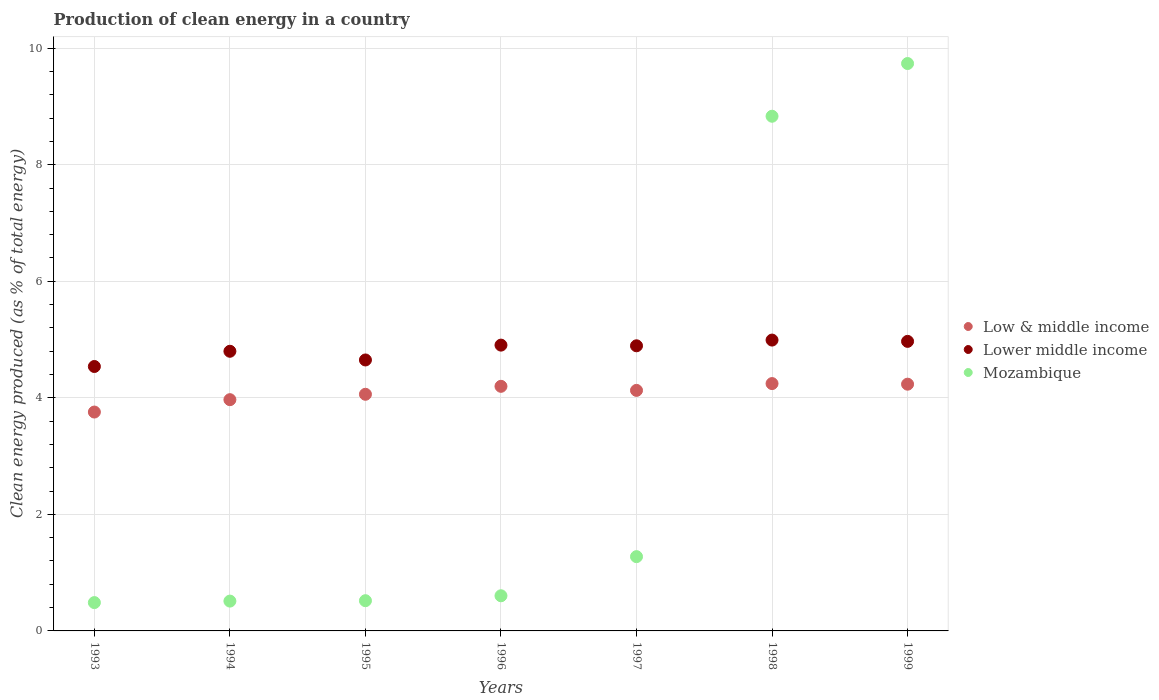How many different coloured dotlines are there?
Your response must be concise. 3. What is the percentage of clean energy produced in Mozambique in 1995?
Offer a very short reply. 0.52. Across all years, what is the maximum percentage of clean energy produced in Mozambique?
Your answer should be very brief. 9.74. Across all years, what is the minimum percentage of clean energy produced in Lower middle income?
Give a very brief answer. 4.54. What is the total percentage of clean energy produced in Mozambique in the graph?
Your response must be concise. 21.96. What is the difference between the percentage of clean energy produced in Low & middle income in 1998 and that in 1999?
Your response must be concise. 0.01. What is the difference between the percentage of clean energy produced in Low & middle income in 1995 and the percentage of clean energy produced in Mozambique in 1997?
Provide a short and direct response. 2.79. What is the average percentage of clean energy produced in Mozambique per year?
Your answer should be compact. 3.14. In the year 1996, what is the difference between the percentage of clean energy produced in Mozambique and percentage of clean energy produced in Lower middle income?
Your response must be concise. -4.3. In how many years, is the percentage of clean energy produced in Low & middle income greater than 7.6 %?
Give a very brief answer. 0. What is the ratio of the percentage of clean energy produced in Mozambique in 1997 to that in 1999?
Provide a succinct answer. 0.13. Is the difference between the percentage of clean energy produced in Mozambique in 1993 and 1995 greater than the difference between the percentage of clean energy produced in Lower middle income in 1993 and 1995?
Offer a terse response. Yes. What is the difference between the highest and the second highest percentage of clean energy produced in Mozambique?
Make the answer very short. 0.9. What is the difference between the highest and the lowest percentage of clean energy produced in Lower middle income?
Your response must be concise. 0.45. How many years are there in the graph?
Your answer should be compact. 7. What is the difference between two consecutive major ticks on the Y-axis?
Offer a terse response. 2. Are the values on the major ticks of Y-axis written in scientific E-notation?
Your response must be concise. No. Does the graph contain any zero values?
Your answer should be compact. No. Does the graph contain grids?
Offer a very short reply. Yes. How many legend labels are there?
Your answer should be compact. 3. How are the legend labels stacked?
Ensure brevity in your answer.  Vertical. What is the title of the graph?
Your answer should be compact. Production of clean energy in a country. Does "Least developed countries" appear as one of the legend labels in the graph?
Offer a terse response. No. What is the label or title of the Y-axis?
Provide a short and direct response. Clean energy produced (as % of total energy). What is the Clean energy produced (as % of total energy) of Low & middle income in 1993?
Give a very brief answer. 3.76. What is the Clean energy produced (as % of total energy) in Lower middle income in 1993?
Keep it short and to the point. 4.54. What is the Clean energy produced (as % of total energy) in Mozambique in 1993?
Make the answer very short. 0.49. What is the Clean energy produced (as % of total energy) in Low & middle income in 1994?
Give a very brief answer. 3.97. What is the Clean energy produced (as % of total energy) of Lower middle income in 1994?
Ensure brevity in your answer.  4.8. What is the Clean energy produced (as % of total energy) in Mozambique in 1994?
Ensure brevity in your answer.  0.51. What is the Clean energy produced (as % of total energy) in Low & middle income in 1995?
Offer a very short reply. 4.06. What is the Clean energy produced (as % of total energy) in Lower middle income in 1995?
Keep it short and to the point. 4.65. What is the Clean energy produced (as % of total energy) of Mozambique in 1995?
Provide a succinct answer. 0.52. What is the Clean energy produced (as % of total energy) in Low & middle income in 1996?
Offer a very short reply. 4.2. What is the Clean energy produced (as % of total energy) of Lower middle income in 1996?
Give a very brief answer. 4.9. What is the Clean energy produced (as % of total energy) of Mozambique in 1996?
Ensure brevity in your answer.  0.6. What is the Clean energy produced (as % of total energy) in Low & middle income in 1997?
Ensure brevity in your answer.  4.13. What is the Clean energy produced (as % of total energy) of Lower middle income in 1997?
Provide a succinct answer. 4.89. What is the Clean energy produced (as % of total energy) in Mozambique in 1997?
Keep it short and to the point. 1.27. What is the Clean energy produced (as % of total energy) of Low & middle income in 1998?
Give a very brief answer. 4.24. What is the Clean energy produced (as % of total energy) of Lower middle income in 1998?
Provide a succinct answer. 4.99. What is the Clean energy produced (as % of total energy) in Mozambique in 1998?
Your answer should be very brief. 8.83. What is the Clean energy produced (as % of total energy) of Low & middle income in 1999?
Your response must be concise. 4.23. What is the Clean energy produced (as % of total energy) of Lower middle income in 1999?
Offer a very short reply. 4.97. What is the Clean energy produced (as % of total energy) in Mozambique in 1999?
Your answer should be compact. 9.74. Across all years, what is the maximum Clean energy produced (as % of total energy) in Low & middle income?
Your answer should be compact. 4.24. Across all years, what is the maximum Clean energy produced (as % of total energy) of Lower middle income?
Make the answer very short. 4.99. Across all years, what is the maximum Clean energy produced (as % of total energy) in Mozambique?
Make the answer very short. 9.74. Across all years, what is the minimum Clean energy produced (as % of total energy) in Low & middle income?
Make the answer very short. 3.76. Across all years, what is the minimum Clean energy produced (as % of total energy) of Lower middle income?
Your answer should be very brief. 4.54. Across all years, what is the minimum Clean energy produced (as % of total energy) of Mozambique?
Give a very brief answer. 0.49. What is the total Clean energy produced (as % of total energy) of Low & middle income in the graph?
Provide a short and direct response. 28.59. What is the total Clean energy produced (as % of total energy) of Lower middle income in the graph?
Keep it short and to the point. 33.74. What is the total Clean energy produced (as % of total energy) in Mozambique in the graph?
Offer a very short reply. 21.96. What is the difference between the Clean energy produced (as % of total energy) of Low & middle income in 1993 and that in 1994?
Provide a short and direct response. -0.21. What is the difference between the Clean energy produced (as % of total energy) in Lower middle income in 1993 and that in 1994?
Offer a terse response. -0.26. What is the difference between the Clean energy produced (as % of total energy) in Mozambique in 1993 and that in 1994?
Provide a short and direct response. -0.03. What is the difference between the Clean energy produced (as % of total energy) of Low & middle income in 1993 and that in 1995?
Give a very brief answer. -0.3. What is the difference between the Clean energy produced (as % of total energy) in Lower middle income in 1993 and that in 1995?
Your response must be concise. -0.11. What is the difference between the Clean energy produced (as % of total energy) in Mozambique in 1993 and that in 1995?
Offer a very short reply. -0.03. What is the difference between the Clean energy produced (as % of total energy) of Low & middle income in 1993 and that in 1996?
Offer a terse response. -0.44. What is the difference between the Clean energy produced (as % of total energy) in Lower middle income in 1993 and that in 1996?
Offer a very short reply. -0.37. What is the difference between the Clean energy produced (as % of total energy) in Mozambique in 1993 and that in 1996?
Your answer should be compact. -0.12. What is the difference between the Clean energy produced (as % of total energy) in Low & middle income in 1993 and that in 1997?
Make the answer very short. -0.37. What is the difference between the Clean energy produced (as % of total energy) in Lower middle income in 1993 and that in 1997?
Your response must be concise. -0.36. What is the difference between the Clean energy produced (as % of total energy) in Mozambique in 1993 and that in 1997?
Your response must be concise. -0.79. What is the difference between the Clean energy produced (as % of total energy) in Low & middle income in 1993 and that in 1998?
Ensure brevity in your answer.  -0.49. What is the difference between the Clean energy produced (as % of total energy) in Lower middle income in 1993 and that in 1998?
Your answer should be compact. -0.45. What is the difference between the Clean energy produced (as % of total energy) of Mozambique in 1993 and that in 1998?
Give a very brief answer. -8.35. What is the difference between the Clean energy produced (as % of total energy) of Low & middle income in 1993 and that in 1999?
Your answer should be very brief. -0.48. What is the difference between the Clean energy produced (as % of total energy) of Lower middle income in 1993 and that in 1999?
Your response must be concise. -0.43. What is the difference between the Clean energy produced (as % of total energy) in Mozambique in 1993 and that in 1999?
Offer a terse response. -9.25. What is the difference between the Clean energy produced (as % of total energy) of Low & middle income in 1994 and that in 1995?
Provide a short and direct response. -0.09. What is the difference between the Clean energy produced (as % of total energy) of Lower middle income in 1994 and that in 1995?
Offer a terse response. 0.15. What is the difference between the Clean energy produced (as % of total energy) in Mozambique in 1994 and that in 1995?
Give a very brief answer. -0.01. What is the difference between the Clean energy produced (as % of total energy) of Low & middle income in 1994 and that in 1996?
Your answer should be compact. -0.23. What is the difference between the Clean energy produced (as % of total energy) of Lower middle income in 1994 and that in 1996?
Offer a terse response. -0.11. What is the difference between the Clean energy produced (as % of total energy) in Mozambique in 1994 and that in 1996?
Your answer should be compact. -0.09. What is the difference between the Clean energy produced (as % of total energy) of Low & middle income in 1994 and that in 1997?
Give a very brief answer. -0.16. What is the difference between the Clean energy produced (as % of total energy) in Lower middle income in 1994 and that in 1997?
Offer a terse response. -0.09. What is the difference between the Clean energy produced (as % of total energy) of Mozambique in 1994 and that in 1997?
Provide a short and direct response. -0.76. What is the difference between the Clean energy produced (as % of total energy) in Low & middle income in 1994 and that in 1998?
Your answer should be very brief. -0.28. What is the difference between the Clean energy produced (as % of total energy) in Lower middle income in 1994 and that in 1998?
Your response must be concise. -0.19. What is the difference between the Clean energy produced (as % of total energy) in Mozambique in 1994 and that in 1998?
Ensure brevity in your answer.  -8.32. What is the difference between the Clean energy produced (as % of total energy) of Low & middle income in 1994 and that in 1999?
Your answer should be very brief. -0.27. What is the difference between the Clean energy produced (as % of total energy) of Lower middle income in 1994 and that in 1999?
Offer a very short reply. -0.17. What is the difference between the Clean energy produced (as % of total energy) in Mozambique in 1994 and that in 1999?
Your response must be concise. -9.22. What is the difference between the Clean energy produced (as % of total energy) in Low & middle income in 1995 and that in 1996?
Provide a succinct answer. -0.14. What is the difference between the Clean energy produced (as % of total energy) of Lower middle income in 1995 and that in 1996?
Offer a very short reply. -0.25. What is the difference between the Clean energy produced (as % of total energy) of Mozambique in 1995 and that in 1996?
Offer a terse response. -0.08. What is the difference between the Clean energy produced (as % of total energy) of Low & middle income in 1995 and that in 1997?
Ensure brevity in your answer.  -0.07. What is the difference between the Clean energy produced (as % of total energy) in Lower middle income in 1995 and that in 1997?
Provide a succinct answer. -0.24. What is the difference between the Clean energy produced (as % of total energy) in Mozambique in 1995 and that in 1997?
Make the answer very short. -0.76. What is the difference between the Clean energy produced (as % of total energy) in Low & middle income in 1995 and that in 1998?
Offer a very short reply. -0.18. What is the difference between the Clean energy produced (as % of total energy) in Lower middle income in 1995 and that in 1998?
Give a very brief answer. -0.34. What is the difference between the Clean energy produced (as % of total energy) in Mozambique in 1995 and that in 1998?
Offer a terse response. -8.31. What is the difference between the Clean energy produced (as % of total energy) in Low & middle income in 1995 and that in 1999?
Give a very brief answer. -0.17. What is the difference between the Clean energy produced (as % of total energy) of Lower middle income in 1995 and that in 1999?
Keep it short and to the point. -0.32. What is the difference between the Clean energy produced (as % of total energy) in Mozambique in 1995 and that in 1999?
Give a very brief answer. -9.22. What is the difference between the Clean energy produced (as % of total energy) of Low & middle income in 1996 and that in 1997?
Give a very brief answer. 0.07. What is the difference between the Clean energy produced (as % of total energy) in Lower middle income in 1996 and that in 1997?
Your response must be concise. 0.01. What is the difference between the Clean energy produced (as % of total energy) in Mozambique in 1996 and that in 1997?
Make the answer very short. -0.67. What is the difference between the Clean energy produced (as % of total energy) in Low & middle income in 1996 and that in 1998?
Provide a short and direct response. -0.05. What is the difference between the Clean energy produced (as % of total energy) in Lower middle income in 1996 and that in 1998?
Provide a short and direct response. -0.09. What is the difference between the Clean energy produced (as % of total energy) of Mozambique in 1996 and that in 1998?
Offer a very short reply. -8.23. What is the difference between the Clean energy produced (as % of total energy) in Low & middle income in 1996 and that in 1999?
Your answer should be very brief. -0.04. What is the difference between the Clean energy produced (as % of total energy) in Lower middle income in 1996 and that in 1999?
Give a very brief answer. -0.06. What is the difference between the Clean energy produced (as % of total energy) in Mozambique in 1996 and that in 1999?
Your answer should be very brief. -9.13. What is the difference between the Clean energy produced (as % of total energy) of Low & middle income in 1997 and that in 1998?
Offer a terse response. -0.12. What is the difference between the Clean energy produced (as % of total energy) in Lower middle income in 1997 and that in 1998?
Ensure brevity in your answer.  -0.1. What is the difference between the Clean energy produced (as % of total energy) in Mozambique in 1997 and that in 1998?
Your answer should be very brief. -7.56. What is the difference between the Clean energy produced (as % of total energy) in Low & middle income in 1997 and that in 1999?
Provide a short and direct response. -0.11. What is the difference between the Clean energy produced (as % of total energy) of Lower middle income in 1997 and that in 1999?
Ensure brevity in your answer.  -0.08. What is the difference between the Clean energy produced (as % of total energy) in Mozambique in 1997 and that in 1999?
Offer a very short reply. -8.46. What is the difference between the Clean energy produced (as % of total energy) in Low & middle income in 1998 and that in 1999?
Provide a succinct answer. 0.01. What is the difference between the Clean energy produced (as % of total energy) of Lower middle income in 1998 and that in 1999?
Provide a succinct answer. 0.02. What is the difference between the Clean energy produced (as % of total energy) of Mozambique in 1998 and that in 1999?
Your response must be concise. -0.9. What is the difference between the Clean energy produced (as % of total energy) of Low & middle income in 1993 and the Clean energy produced (as % of total energy) of Lower middle income in 1994?
Offer a very short reply. -1.04. What is the difference between the Clean energy produced (as % of total energy) in Low & middle income in 1993 and the Clean energy produced (as % of total energy) in Mozambique in 1994?
Offer a terse response. 3.24. What is the difference between the Clean energy produced (as % of total energy) of Lower middle income in 1993 and the Clean energy produced (as % of total energy) of Mozambique in 1994?
Your answer should be compact. 4.03. What is the difference between the Clean energy produced (as % of total energy) of Low & middle income in 1993 and the Clean energy produced (as % of total energy) of Lower middle income in 1995?
Provide a short and direct response. -0.89. What is the difference between the Clean energy produced (as % of total energy) of Low & middle income in 1993 and the Clean energy produced (as % of total energy) of Mozambique in 1995?
Give a very brief answer. 3.24. What is the difference between the Clean energy produced (as % of total energy) in Lower middle income in 1993 and the Clean energy produced (as % of total energy) in Mozambique in 1995?
Offer a very short reply. 4.02. What is the difference between the Clean energy produced (as % of total energy) of Low & middle income in 1993 and the Clean energy produced (as % of total energy) of Lower middle income in 1996?
Offer a very short reply. -1.15. What is the difference between the Clean energy produced (as % of total energy) in Low & middle income in 1993 and the Clean energy produced (as % of total energy) in Mozambique in 1996?
Ensure brevity in your answer.  3.15. What is the difference between the Clean energy produced (as % of total energy) in Lower middle income in 1993 and the Clean energy produced (as % of total energy) in Mozambique in 1996?
Your answer should be very brief. 3.93. What is the difference between the Clean energy produced (as % of total energy) of Low & middle income in 1993 and the Clean energy produced (as % of total energy) of Lower middle income in 1997?
Provide a short and direct response. -1.14. What is the difference between the Clean energy produced (as % of total energy) of Low & middle income in 1993 and the Clean energy produced (as % of total energy) of Mozambique in 1997?
Offer a very short reply. 2.48. What is the difference between the Clean energy produced (as % of total energy) in Lower middle income in 1993 and the Clean energy produced (as % of total energy) in Mozambique in 1997?
Provide a short and direct response. 3.26. What is the difference between the Clean energy produced (as % of total energy) of Low & middle income in 1993 and the Clean energy produced (as % of total energy) of Lower middle income in 1998?
Provide a short and direct response. -1.24. What is the difference between the Clean energy produced (as % of total energy) in Low & middle income in 1993 and the Clean energy produced (as % of total energy) in Mozambique in 1998?
Offer a terse response. -5.08. What is the difference between the Clean energy produced (as % of total energy) of Lower middle income in 1993 and the Clean energy produced (as % of total energy) of Mozambique in 1998?
Provide a short and direct response. -4.29. What is the difference between the Clean energy produced (as % of total energy) of Low & middle income in 1993 and the Clean energy produced (as % of total energy) of Lower middle income in 1999?
Make the answer very short. -1.21. What is the difference between the Clean energy produced (as % of total energy) in Low & middle income in 1993 and the Clean energy produced (as % of total energy) in Mozambique in 1999?
Offer a terse response. -5.98. What is the difference between the Clean energy produced (as % of total energy) in Lower middle income in 1993 and the Clean energy produced (as % of total energy) in Mozambique in 1999?
Your answer should be compact. -5.2. What is the difference between the Clean energy produced (as % of total energy) in Low & middle income in 1994 and the Clean energy produced (as % of total energy) in Lower middle income in 1995?
Your answer should be very brief. -0.68. What is the difference between the Clean energy produced (as % of total energy) of Low & middle income in 1994 and the Clean energy produced (as % of total energy) of Mozambique in 1995?
Provide a short and direct response. 3.45. What is the difference between the Clean energy produced (as % of total energy) in Lower middle income in 1994 and the Clean energy produced (as % of total energy) in Mozambique in 1995?
Your answer should be very brief. 4.28. What is the difference between the Clean energy produced (as % of total energy) in Low & middle income in 1994 and the Clean energy produced (as % of total energy) in Lower middle income in 1996?
Your answer should be very brief. -0.94. What is the difference between the Clean energy produced (as % of total energy) in Low & middle income in 1994 and the Clean energy produced (as % of total energy) in Mozambique in 1996?
Your response must be concise. 3.37. What is the difference between the Clean energy produced (as % of total energy) in Lower middle income in 1994 and the Clean energy produced (as % of total energy) in Mozambique in 1996?
Provide a succinct answer. 4.2. What is the difference between the Clean energy produced (as % of total energy) of Low & middle income in 1994 and the Clean energy produced (as % of total energy) of Lower middle income in 1997?
Make the answer very short. -0.92. What is the difference between the Clean energy produced (as % of total energy) in Low & middle income in 1994 and the Clean energy produced (as % of total energy) in Mozambique in 1997?
Keep it short and to the point. 2.69. What is the difference between the Clean energy produced (as % of total energy) of Lower middle income in 1994 and the Clean energy produced (as % of total energy) of Mozambique in 1997?
Your answer should be compact. 3.52. What is the difference between the Clean energy produced (as % of total energy) in Low & middle income in 1994 and the Clean energy produced (as % of total energy) in Lower middle income in 1998?
Give a very brief answer. -1.02. What is the difference between the Clean energy produced (as % of total energy) of Low & middle income in 1994 and the Clean energy produced (as % of total energy) of Mozambique in 1998?
Provide a short and direct response. -4.86. What is the difference between the Clean energy produced (as % of total energy) in Lower middle income in 1994 and the Clean energy produced (as % of total energy) in Mozambique in 1998?
Provide a succinct answer. -4.03. What is the difference between the Clean energy produced (as % of total energy) of Low & middle income in 1994 and the Clean energy produced (as % of total energy) of Lower middle income in 1999?
Give a very brief answer. -1. What is the difference between the Clean energy produced (as % of total energy) in Low & middle income in 1994 and the Clean energy produced (as % of total energy) in Mozambique in 1999?
Offer a very short reply. -5.77. What is the difference between the Clean energy produced (as % of total energy) in Lower middle income in 1994 and the Clean energy produced (as % of total energy) in Mozambique in 1999?
Provide a succinct answer. -4.94. What is the difference between the Clean energy produced (as % of total energy) of Low & middle income in 1995 and the Clean energy produced (as % of total energy) of Lower middle income in 1996?
Offer a terse response. -0.84. What is the difference between the Clean energy produced (as % of total energy) of Low & middle income in 1995 and the Clean energy produced (as % of total energy) of Mozambique in 1996?
Provide a succinct answer. 3.46. What is the difference between the Clean energy produced (as % of total energy) in Lower middle income in 1995 and the Clean energy produced (as % of total energy) in Mozambique in 1996?
Ensure brevity in your answer.  4.05. What is the difference between the Clean energy produced (as % of total energy) of Low & middle income in 1995 and the Clean energy produced (as % of total energy) of Lower middle income in 1997?
Your answer should be compact. -0.83. What is the difference between the Clean energy produced (as % of total energy) of Low & middle income in 1995 and the Clean energy produced (as % of total energy) of Mozambique in 1997?
Offer a very short reply. 2.79. What is the difference between the Clean energy produced (as % of total energy) of Lower middle income in 1995 and the Clean energy produced (as % of total energy) of Mozambique in 1997?
Provide a succinct answer. 3.38. What is the difference between the Clean energy produced (as % of total energy) in Low & middle income in 1995 and the Clean energy produced (as % of total energy) in Lower middle income in 1998?
Offer a terse response. -0.93. What is the difference between the Clean energy produced (as % of total energy) in Low & middle income in 1995 and the Clean energy produced (as % of total energy) in Mozambique in 1998?
Make the answer very short. -4.77. What is the difference between the Clean energy produced (as % of total energy) in Lower middle income in 1995 and the Clean energy produced (as % of total energy) in Mozambique in 1998?
Offer a very short reply. -4.18. What is the difference between the Clean energy produced (as % of total energy) of Low & middle income in 1995 and the Clean energy produced (as % of total energy) of Lower middle income in 1999?
Offer a very short reply. -0.91. What is the difference between the Clean energy produced (as % of total energy) of Low & middle income in 1995 and the Clean energy produced (as % of total energy) of Mozambique in 1999?
Give a very brief answer. -5.68. What is the difference between the Clean energy produced (as % of total energy) of Lower middle income in 1995 and the Clean energy produced (as % of total energy) of Mozambique in 1999?
Your response must be concise. -5.09. What is the difference between the Clean energy produced (as % of total energy) in Low & middle income in 1996 and the Clean energy produced (as % of total energy) in Lower middle income in 1997?
Provide a succinct answer. -0.7. What is the difference between the Clean energy produced (as % of total energy) of Low & middle income in 1996 and the Clean energy produced (as % of total energy) of Mozambique in 1997?
Make the answer very short. 2.92. What is the difference between the Clean energy produced (as % of total energy) of Lower middle income in 1996 and the Clean energy produced (as % of total energy) of Mozambique in 1997?
Give a very brief answer. 3.63. What is the difference between the Clean energy produced (as % of total energy) of Low & middle income in 1996 and the Clean energy produced (as % of total energy) of Lower middle income in 1998?
Provide a succinct answer. -0.79. What is the difference between the Clean energy produced (as % of total energy) in Low & middle income in 1996 and the Clean energy produced (as % of total energy) in Mozambique in 1998?
Your answer should be compact. -4.63. What is the difference between the Clean energy produced (as % of total energy) in Lower middle income in 1996 and the Clean energy produced (as % of total energy) in Mozambique in 1998?
Provide a succinct answer. -3.93. What is the difference between the Clean energy produced (as % of total energy) of Low & middle income in 1996 and the Clean energy produced (as % of total energy) of Lower middle income in 1999?
Offer a terse response. -0.77. What is the difference between the Clean energy produced (as % of total energy) in Low & middle income in 1996 and the Clean energy produced (as % of total energy) in Mozambique in 1999?
Provide a succinct answer. -5.54. What is the difference between the Clean energy produced (as % of total energy) in Lower middle income in 1996 and the Clean energy produced (as % of total energy) in Mozambique in 1999?
Make the answer very short. -4.83. What is the difference between the Clean energy produced (as % of total energy) in Low & middle income in 1997 and the Clean energy produced (as % of total energy) in Lower middle income in 1998?
Make the answer very short. -0.86. What is the difference between the Clean energy produced (as % of total energy) in Low & middle income in 1997 and the Clean energy produced (as % of total energy) in Mozambique in 1998?
Provide a succinct answer. -4.7. What is the difference between the Clean energy produced (as % of total energy) of Lower middle income in 1997 and the Clean energy produced (as % of total energy) of Mozambique in 1998?
Keep it short and to the point. -3.94. What is the difference between the Clean energy produced (as % of total energy) of Low & middle income in 1997 and the Clean energy produced (as % of total energy) of Lower middle income in 1999?
Provide a succinct answer. -0.84. What is the difference between the Clean energy produced (as % of total energy) in Low & middle income in 1997 and the Clean energy produced (as % of total energy) in Mozambique in 1999?
Provide a succinct answer. -5.61. What is the difference between the Clean energy produced (as % of total energy) in Lower middle income in 1997 and the Clean energy produced (as % of total energy) in Mozambique in 1999?
Keep it short and to the point. -4.84. What is the difference between the Clean energy produced (as % of total energy) of Low & middle income in 1998 and the Clean energy produced (as % of total energy) of Lower middle income in 1999?
Your answer should be very brief. -0.72. What is the difference between the Clean energy produced (as % of total energy) in Low & middle income in 1998 and the Clean energy produced (as % of total energy) in Mozambique in 1999?
Your answer should be compact. -5.49. What is the difference between the Clean energy produced (as % of total energy) in Lower middle income in 1998 and the Clean energy produced (as % of total energy) in Mozambique in 1999?
Your answer should be very brief. -4.75. What is the average Clean energy produced (as % of total energy) in Low & middle income per year?
Give a very brief answer. 4.08. What is the average Clean energy produced (as % of total energy) of Lower middle income per year?
Provide a short and direct response. 4.82. What is the average Clean energy produced (as % of total energy) in Mozambique per year?
Provide a short and direct response. 3.14. In the year 1993, what is the difference between the Clean energy produced (as % of total energy) of Low & middle income and Clean energy produced (as % of total energy) of Lower middle income?
Give a very brief answer. -0.78. In the year 1993, what is the difference between the Clean energy produced (as % of total energy) in Low & middle income and Clean energy produced (as % of total energy) in Mozambique?
Keep it short and to the point. 3.27. In the year 1993, what is the difference between the Clean energy produced (as % of total energy) in Lower middle income and Clean energy produced (as % of total energy) in Mozambique?
Provide a succinct answer. 4.05. In the year 1994, what is the difference between the Clean energy produced (as % of total energy) of Low & middle income and Clean energy produced (as % of total energy) of Lower middle income?
Your response must be concise. -0.83. In the year 1994, what is the difference between the Clean energy produced (as % of total energy) in Low & middle income and Clean energy produced (as % of total energy) in Mozambique?
Make the answer very short. 3.46. In the year 1994, what is the difference between the Clean energy produced (as % of total energy) of Lower middle income and Clean energy produced (as % of total energy) of Mozambique?
Give a very brief answer. 4.29. In the year 1995, what is the difference between the Clean energy produced (as % of total energy) in Low & middle income and Clean energy produced (as % of total energy) in Lower middle income?
Provide a short and direct response. -0.59. In the year 1995, what is the difference between the Clean energy produced (as % of total energy) in Low & middle income and Clean energy produced (as % of total energy) in Mozambique?
Offer a very short reply. 3.54. In the year 1995, what is the difference between the Clean energy produced (as % of total energy) of Lower middle income and Clean energy produced (as % of total energy) of Mozambique?
Your response must be concise. 4.13. In the year 1996, what is the difference between the Clean energy produced (as % of total energy) of Low & middle income and Clean energy produced (as % of total energy) of Lower middle income?
Your answer should be compact. -0.71. In the year 1996, what is the difference between the Clean energy produced (as % of total energy) in Low & middle income and Clean energy produced (as % of total energy) in Mozambique?
Ensure brevity in your answer.  3.59. In the year 1996, what is the difference between the Clean energy produced (as % of total energy) in Lower middle income and Clean energy produced (as % of total energy) in Mozambique?
Offer a very short reply. 4.3. In the year 1997, what is the difference between the Clean energy produced (as % of total energy) of Low & middle income and Clean energy produced (as % of total energy) of Lower middle income?
Provide a succinct answer. -0.77. In the year 1997, what is the difference between the Clean energy produced (as % of total energy) in Low & middle income and Clean energy produced (as % of total energy) in Mozambique?
Offer a terse response. 2.85. In the year 1997, what is the difference between the Clean energy produced (as % of total energy) in Lower middle income and Clean energy produced (as % of total energy) in Mozambique?
Your response must be concise. 3.62. In the year 1998, what is the difference between the Clean energy produced (as % of total energy) in Low & middle income and Clean energy produced (as % of total energy) in Lower middle income?
Give a very brief answer. -0.75. In the year 1998, what is the difference between the Clean energy produced (as % of total energy) of Low & middle income and Clean energy produced (as % of total energy) of Mozambique?
Offer a terse response. -4.59. In the year 1998, what is the difference between the Clean energy produced (as % of total energy) in Lower middle income and Clean energy produced (as % of total energy) in Mozambique?
Make the answer very short. -3.84. In the year 1999, what is the difference between the Clean energy produced (as % of total energy) of Low & middle income and Clean energy produced (as % of total energy) of Lower middle income?
Provide a succinct answer. -0.73. In the year 1999, what is the difference between the Clean energy produced (as % of total energy) in Low & middle income and Clean energy produced (as % of total energy) in Mozambique?
Offer a very short reply. -5.5. In the year 1999, what is the difference between the Clean energy produced (as % of total energy) in Lower middle income and Clean energy produced (as % of total energy) in Mozambique?
Ensure brevity in your answer.  -4.77. What is the ratio of the Clean energy produced (as % of total energy) of Low & middle income in 1993 to that in 1994?
Offer a terse response. 0.95. What is the ratio of the Clean energy produced (as % of total energy) of Lower middle income in 1993 to that in 1994?
Make the answer very short. 0.95. What is the ratio of the Clean energy produced (as % of total energy) in Mozambique in 1993 to that in 1994?
Your answer should be very brief. 0.95. What is the ratio of the Clean energy produced (as % of total energy) of Low & middle income in 1993 to that in 1995?
Give a very brief answer. 0.92. What is the ratio of the Clean energy produced (as % of total energy) of Lower middle income in 1993 to that in 1995?
Ensure brevity in your answer.  0.98. What is the ratio of the Clean energy produced (as % of total energy) of Mozambique in 1993 to that in 1995?
Offer a terse response. 0.94. What is the ratio of the Clean energy produced (as % of total energy) in Low & middle income in 1993 to that in 1996?
Your answer should be compact. 0.89. What is the ratio of the Clean energy produced (as % of total energy) of Lower middle income in 1993 to that in 1996?
Your answer should be compact. 0.93. What is the ratio of the Clean energy produced (as % of total energy) in Mozambique in 1993 to that in 1996?
Your answer should be compact. 0.81. What is the ratio of the Clean energy produced (as % of total energy) of Low & middle income in 1993 to that in 1997?
Give a very brief answer. 0.91. What is the ratio of the Clean energy produced (as % of total energy) of Lower middle income in 1993 to that in 1997?
Offer a very short reply. 0.93. What is the ratio of the Clean energy produced (as % of total energy) of Mozambique in 1993 to that in 1997?
Your answer should be very brief. 0.38. What is the ratio of the Clean energy produced (as % of total energy) of Low & middle income in 1993 to that in 1998?
Offer a very short reply. 0.88. What is the ratio of the Clean energy produced (as % of total energy) in Lower middle income in 1993 to that in 1998?
Provide a succinct answer. 0.91. What is the ratio of the Clean energy produced (as % of total energy) of Mozambique in 1993 to that in 1998?
Your answer should be compact. 0.06. What is the ratio of the Clean energy produced (as % of total energy) of Low & middle income in 1993 to that in 1999?
Your answer should be very brief. 0.89. What is the ratio of the Clean energy produced (as % of total energy) in Lower middle income in 1993 to that in 1999?
Your response must be concise. 0.91. What is the ratio of the Clean energy produced (as % of total energy) in Mozambique in 1993 to that in 1999?
Your response must be concise. 0.05. What is the ratio of the Clean energy produced (as % of total energy) of Low & middle income in 1994 to that in 1995?
Your answer should be compact. 0.98. What is the ratio of the Clean energy produced (as % of total energy) of Lower middle income in 1994 to that in 1995?
Your answer should be compact. 1.03. What is the ratio of the Clean energy produced (as % of total energy) in Mozambique in 1994 to that in 1995?
Ensure brevity in your answer.  0.99. What is the ratio of the Clean energy produced (as % of total energy) in Low & middle income in 1994 to that in 1996?
Offer a very short reply. 0.95. What is the ratio of the Clean energy produced (as % of total energy) of Lower middle income in 1994 to that in 1996?
Offer a very short reply. 0.98. What is the ratio of the Clean energy produced (as % of total energy) of Mozambique in 1994 to that in 1996?
Offer a very short reply. 0.85. What is the ratio of the Clean energy produced (as % of total energy) in Low & middle income in 1994 to that in 1997?
Give a very brief answer. 0.96. What is the ratio of the Clean energy produced (as % of total energy) in Lower middle income in 1994 to that in 1997?
Offer a very short reply. 0.98. What is the ratio of the Clean energy produced (as % of total energy) of Mozambique in 1994 to that in 1997?
Ensure brevity in your answer.  0.4. What is the ratio of the Clean energy produced (as % of total energy) in Low & middle income in 1994 to that in 1998?
Provide a short and direct response. 0.93. What is the ratio of the Clean energy produced (as % of total energy) in Lower middle income in 1994 to that in 1998?
Offer a terse response. 0.96. What is the ratio of the Clean energy produced (as % of total energy) of Mozambique in 1994 to that in 1998?
Keep it short and to the point. 0.06. What is the ratio of the Clean energy produced (as % of total energy) in Low & middle income in 1994 to that in 1999?
Provide a short and direct response. 0.94. What is the ratio of the Clean energy produced (as % of total energy) in Lower middle income in 1994 to that in 1999?
Provide a short and direct response. 0.97. What is the ratio of the Clean energy produced (as % of total energy) of Mozambique in 1994 to that in 1999?
Provide a succinct answer. 0.05. What is the ratio of the Clean energy produced (as % of total energy) in Low & middle income in 1995 to that in 1996?
Provide a succinct answer. 0.97. What is the ratio of the Clean energy produced (as % of total energy) of Lower middle income in 1995 to that in 1996?
Your answer should be compact. 0.95. What is the ratio of the Clean energy produced (as % of total energy) of Mozambique in 1995 to that in 1996?
Give a very brief answer. 0.86. What is the ratio of the Clean energy produced (as % of total energy) of Low & middle income in 1995 to that in 1997?
Keep it short and to the point. 0.98. What is the ratio of the Clean energy produced (as % of total energy) of Lower middle income in 1995 to that in 1997?
Your answer should be compact. 0.95. What is the ratio of the Clean energy produced (as % of total energy) of Mozambique in 1995 to that in 1997?
Your answer should be compact. 0.41. What is the ratio of the Clean energy produced (as % of total energy) of Low & middle income in 1995 to that in 1998?
Ensure brevity in your answer.  0.96. What is the ratio of the Clean energy produced (as % of total energy) of Lower middle income in 1995 to that in 1998?
Offer a very short reply. 0.93. What is the ratio of the Clean energy produced (as % of total energy) of Mozambique in 1995 to that in 1998?
Offer a terse response. 0.06. What is the ratio of the Clean energy produced (as % of total energy) of Low & middle income in 1995 to that in 1999?
Offer a very short reply. 0.96. What is the ratio of the Clean energy produced (as % of total energy) in Lower middle income in 1995 to that in 1999?
Your response must be concise. 0.94. What is the ratio of the Clean energy produced (as % of total energy) of Mozambique in 1995 to that in 1999?
Your answer should be very brief. 0.05. What is the ratio of the Clean energy produced (as % of total energy) in Low & middle income in 1996 to that in 1997?
Your answer should be very brief. 1.02. What is the ratio of the Clean energy produced (as % of total energy) in Mozambique in 1996 to that in 1997?
Provide a short and direct response. 0.47. What is the ratio of the Clean energy produced (as % of total energy) of Low & middle income in 1996 to that in 1998?
Your answer should be compact. 0.99. What is the ratio of the Clean energy produced (as % of total energy) of Lower middle income in 1996 to that in 1998?
Provide a short and direct response. 0.98. What is the ratio of the Clean energy produced (as % of total energy) in Mozambique in 1996 to that in 1998?
Provide a short and direct response. 0.07. What is the ratio of the Clean energy produced (as % of total energy) of Low & middle income in 1996 to that in 1999?
Provide a succinct answer. 0.99. What is the ratio of the Clean energy produced (as % of total energy) in Mozambique in 1996 to that in 1999?
Provide a short and direct response. 0.06. What is the ratio of the Clean energy produced (as % of total energy) of Low & middle income in 1997 to that in 1998?
Provide a short and direct response. 0.97. What is the ratio of the Clean energy produced (as % of total energy) in Lower middle income in 1997 to that in 1998?
Provide a short and direct response. 0.98. What is the ratio of the Clean energy produced (as % of total energy) in Mozambique in 1997 to that in 1998?
Offer a very short reply. 0.14. What is the ratio of the Clean energy produced (as % of total energy) of Low & middle income in 1997 to that in 1999?
Give a very brief answer. 0.97. What is the ratio of the Clean energy produced (as % of total energy) in Lower middle income in 1997 to that in 1999?
Keep it short and to the point. 0.98. What is the ratio of the Clean energy produced (as % of total energy) in Mozambique in 1997 to that in 1999?
Keep it short and to the point. 0.13. What is the ratio of the Clean energy produced (as % of total energy) in Lower middle income in 1998 to that in 1999?
Provide a succinct answer. 1. What is the ratio of the Clean energy produced (as % of total energy) in Mozambique in 1998 to that in 1999?
Give a very brief answer. 0.91. What is the difference between the highest and the second highest Clean energy produced (as % of total energy) in Low & middle income?
Ensure brevity in your answer.  0.01. What is the difference between the highest and the second highest Clean energy produced (as % of total energy) of Lower middle income?
Your answer should be compact. 0.02. What is the difference between the highest and the second highest Clean energy produced (as % of total energy) of Mozambique?
Offer a very short reply. 0.9. What is the difference between the highest and the lowest Clean energy produced (as % of total energy) in Low & middle income?
Make the answer very short. 0.49. What is the difference between the highest and the lowest Clean energy produced (as % of total energy) of Lower middle income?
Ensure brevity in your answer.  0.45. What is the difference between the highest and the lowest Clean energy produced (as % of total energy) in Mozambique?
Your answer should be very brief. 9.25. 